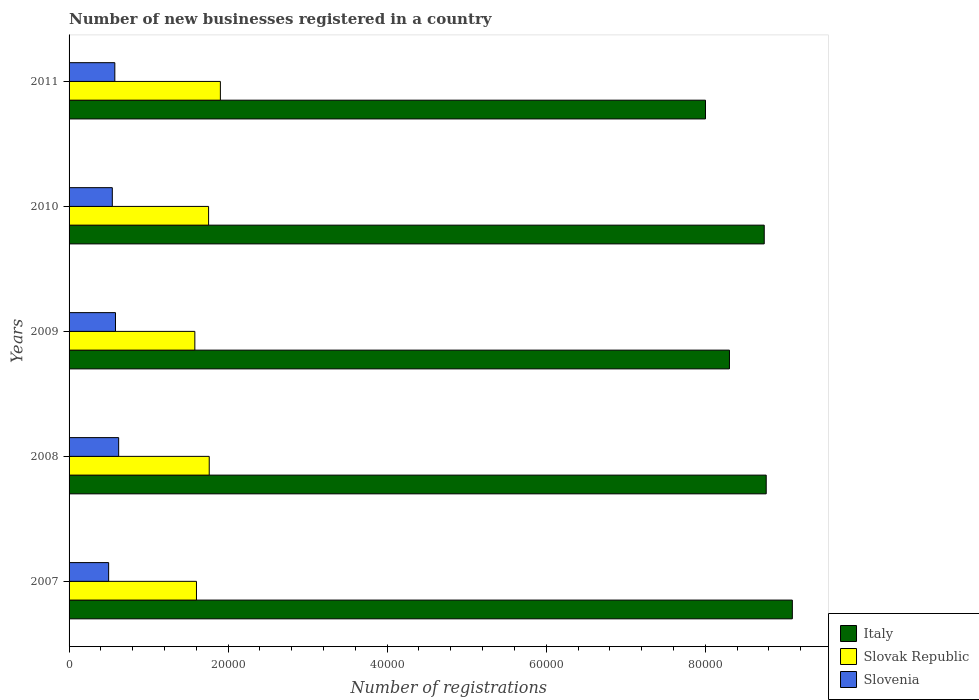How many different coloured bars are there?
Give a very brief answer. 3. Are the number of bars on each tick of the Y-axis equal?
Make the answer very short. Yes. How many bars are there on the 5th tick from the bottom?
Offer a very short reply. 3. What is the label of the 1st group of bars from the top?
Provide a succinct answer. 2011. In how many cases, is the number of bars for a given year not equal to the number of legend labels?
Your response must be concise. 0. What is the number of new businesses registered in Italy in 2010?
Provide a short and direct response. 8.74e+04. Across all years, what is the maximum number of new businesses registered in Slovenia?
Keep it short and to the point. 6235. Across all years, what is the minimum number of new businesses registered in Italy?
Offer a very short reply. 8.00e+04. In which year was the number of new businesses registered in Slovak Republic maximum?
Provide a short and direct response. 2011. What is the total number of new businesses registered in Italy in the graph?
Provide a succinct answer. 4.29e+05. What is the difference between the number of new businesses registered in Slovak Republic in 2009 and that in 2011?
Offer a terse response. -3211. What is the difference between the number of new businesses registered in Italy in 2009 and the number of new businesses registered in Slovak Republic in 2011?
Provide a succinct answer. 6.40e+04. What is the average number of new businesses registered in Slovak Republic per year?
Your answer should be compact. 1.72e+04. In the year 2009, what is the difference between the number of new businesses registered in Slovak Republic and number of new businesses registered in Slovenia?
Provide a succinct answer. 9979. In how many years, is the number of new businesses registered in Slovenia greater than 60000 ?
Provide a short and direct response. 0. What is the ratio of the number of new businesses registered in Italy in 2009 to that in 2011?
Provide a succinct answer. 1.04. Is the number of new businesses registered in Slovak Republic in 2010 less than that in 2011?
Provide a succinct answer. Yes. What is the difference between the highest and the second highest number of new businesses registered in Slovak Republic?
Offer a very short reply. 1401. What is the difference between the highest and the lowest number of new businesses registered in Slovenia?
Keep it short and to the point. 1259. In how many years, is the number of new businesses registered in Italy greater than the average number of new businesses registered in Italy taken over all years?
Provide a succinct answer. 3. Is the sum of the number of new businesses registered in Slovenia in 2010 and 2011 greater than the maximum number of new businesses registered in Slovak Republic across all years?
Give a very brief answer. No. What does the 2nd bar from the bottom in 2009 represents?
Give a very brief answer. Slovak Republic. Is it the case that in every year, the sum of the number of new businesses registered in Slovenia and number of new businesses registered in Slovak Republic is greater than the number of new businesses registered in Italy?
Provide a succinct answer. No. Are all the bars in the graph horizontal?
Offer a very short reply. Yes. What is the difference between two consecutive major ticks on the X-axis?
Provide a succinct answer. 2.00e+04. Does the graph contain any zero values?
Your response must be concise. No. Does the graph contain grids?
Provide a succinct answer. No. Where does the legend appear in the graph?
Offer a very short reply. Bottom right. How many legend labels are there?
Your answer should be very brief. 3. How are the legend labels stacked?
Provide a short and direct response. Vertical. What is the title of the graph?
Your response must be concise. Number of new businesses registered in a country. What is the label or title of the X-axis?
Your answer should be very brief. Number of registrations. What is the label or title of the Y-axis?
Ensure brevity in your answer.  Years. What is the Number of registrations in Italy in 2007?
Provide a succinct answer. 9.10e+04. What is the Number of registrations of Slovak Republic in 2007?
Your response must be concise. 1.60e+04. What is the Number of registrations of Slovenia in 2007?
Provide a succinct answer. 4976. What is the Number of registrations of Italy in 2008?
Your answer should be compact. 8.77e+04. What is the Number of registrations in Slovak Republic in 2008?
Ensure brevity in your answer.  1.76e+04. What is the Number of registrations in Slovenia in 2008?
Your answer should be very brief. 6235. What is the Number of registrations of Italy in 2009?
Provide a short and direct response. 8.30e+04. What is the Number of registrations of Slovak Republic in 2009?
Offer a terse response. 1.58e+04. What is the Number of registrations in Slovenia in 2009?
Ensure brevity in your answer.  5836. What is the Number of registrations of Italy in 2010?
Your answer should be very brief. 8.74e+04. What is the Number of registrations of Slovak Republic in 2010?
Make the answer very short. 1.75e+04. What is the Number of registrations of Slovenia in 2010?
Your response must be concise. 5438. What is the Number of registrations of Italy in 2011?
Your response must be concise. 8.00e+04. What is the Number of registrations in Slovak Republic in 2011?
Offer a very short reply. 1.90e+04. What is the Number of registrations in Slovenia in 2011?
Your answer should be very brief. 5754. Across all years, what is the maximum Number of registrations of Italy?
Give a very brief answer. 9.10e+04. Across all years, what is the maximum Number of registrations of Slovak Republic?
Provide a succinct answer. 1.90e+04. Across all years, what is the maximum Number of registrations of Slovenia?
Offer a very short reply. 6235. Across all years, what is the minimum Number of registrations in Italy?
Your answer should be compact. 8.00e+04. Across all years, what is the minimum Number of registrations of Slovak Republic?
Your answer should be very brief. 1.58e+04. Across all years, what is the minimum Number of registrations in Slovenia?
Keep it short and to the point. 4976. What is the total Number of registrations in Italy in the graph?
Keep it short and to the point. 4.29e+05. What is the total Number of registrations in Slovak Republic in the graph?
Give a very brief answer. 8.60e+04. What is the total Number of registrations of Slovenia in the graph?
Your response must be concise. 2.82e+04. What is the difference between the Number of registrations of Italy in 2007 and that in 2008?
Your answer should be very brief. 3285. What is the difference between the Number of registrations in Slovak Republic in 2007 and that in 2008?
Provide a short and direct response. -1605. What is the difference between the Number of registrations of Slovenia in 2007 and that in 2008?
Provide a succinct answer. -1259. What is the difference between the Number of registrations in Italy in 2007 and that in 2009?
Your response must be concise. 7908. What is the difference between the Number of registrations of Slovak Republic in 2007 and that in 2009?
Your response must be concise. 205. What is the difference between the Number of registrations in Slovenia in 2007 and that in 2009?
Your answer should be compact. -860. What is the difference between the Number of registrations in Italy in 2007 and that in 2010?
Offer a terse response. 3535. What is the difference between the Number of registrations of Slovak Republic in 2007 and that in 2010?
Keep it short and to the point. -1524. What is the difference between the Number of registrations in Slovenia in 2007 and that in 2010?
Give a very brief answer. -462. What is the difference between the Number of registrations of Italy in 2007 and that in 2011?
Offer a very short reply. 1.09e+04. What is the difference between the Number of registrations in Slovak Republic in 2007 and that in 2011?
Your answer should be compact. -3006. What is the difference between the Number of registrations in Slovenia in 2007 and that in 2011?
Provide a short and direct response. -778. What is the difference between the Number of registrations in Italy in 2008 and that in 2009?
Ensure brevity in your answer.  4623. What is the difference between the Number of registrations of Slovak Republic in 2008 and that in 2009?
Offer a very short reply. 1810. What is the difference between the Number of registrations of Slovenia in 2008 and that in 2009?
Offer a terse response. 399. What is the difference between the Number of registrations of Italy in 2008 and that in 2010?
Offer a terse response. 250. What is the difference between the Number of registrations in Slovak Republic in 2008 and that in 2010?
Give a very brief answer. 81. What is the difference between the Number of registrations of Slovenia in 2008 and that in 2010?
Your response must be concise. 797. What is the difference between the Number of registrations in Italy in 2008 and that in 2011?
Your answer should be very brief. 7637. What is the difference between the Number of registrations of Slovak Republic in 2008 and that in 2011?
Give a very brief answer. -1401. What is the difference between the Number of registrations in Slovenia in 2008 and that in 2011?
Give a very brief answer. 481. What is the difference between the Number of registrations in Italy in 2009 and that in 2010?
Give a very brief answer. -4373. What is the difference between the Number of registrations in Slovak Republic in 2009 and that in 2010?
Give a very brief answer. -1729. What is the difference between the Number of registrations in Slovenia in 2009 and that in 2010?
Provide a succinct answer. 398. What is the difference between the Number of registrations in Italy in 2009 and that in 2011?
Offer a terse response. 3014. What is the difference between the Number of registrations of Slovak Republic in 2009 and that in 2011?
Your answer should be compact. -3211. What is the difference between the Number of registrations in Slovenia in 2009 and that in 2011?
Your answer should be very brief. 82. What is the difference between the Number of registrations in Italy in 2010 and that in 2011?
Offer a very short reply. 7387. What is the difference between the Number of registrations of Slovak Republic in 2010 and that in 2011?
Provide a short and direct response. -1482. What is the difference between the Number of registrations of Slovenia in 2010 and that in 2011?
Give a very brief answer. -316. What is the difference between the Number of registrations in Italy in 2007 and the Number of registrations in Slovak Republic in 2008?
Your response must be concise. 7.33e+04. What is the difference between the Number of registrations of Italy in 2007 and the Number of registrations of Slovenia in 2008?
Your response must be concise. 8.47e+04. What is the difference between the Number of registrations in Slovak Republic in 2007 and the Number of registrations in Slovenia in 2008?
Provide a short and direct response. 9785. What is the difference between the Number of registrations of Italy in 2007 and the Number of registrations of Slovak Republic in 2009?
Your response must be concise. 7.51e+04. What is the difference between the Number of registrations of Italy in 2007 and the Number of registrations of Slovenia in 2009?
Provide a succinct answer. 8.51e+04. What is the difference between the Number of registrations in Slovak Republic in 2007 and the Number of registrations in Slovenia in 2009?
Provide a short and direct response. 1.02e+04. What is the difference between the Number of registrations in Italy in 2007 and the Number of registrations in Slovak Republic in 2010?
Your response must be concise. 7.34e+04. What is the difference between the Number of registrations in Italy in 2007 and the Number of registrations in Slovenia in 2010?
Your response must be concise. 8.55e+04. What is the difference between the Number of registrations of Slovak Republic in 2007 and the Number of registrations of Slovenia in 2010?
Your answer should be very brief. 1.06e+04. What is the difference between the Number of registrations of Italy in 2007 and the Number of registrations of Slovak Republic in 2011?
Provide a succinct answer. 7.19e+04. What is the difference between the Number of registrations in Italy in 2007 and the Number of registrations in Slovenia in 2011?
Your answer should be compact. 8.52e+04. What is the difference between the Number of registrations of Slovak Republic in 2007 and the Number of registrations of Slovenia in 2011?
Your response must be concise. 1.03e+04. What is the difference between the Number of registrations of Italy in 2008 and the Number of registrations of Slovak Republic in 2009?
Give a very brief answer. 7.18e+04. What is the difference between the Number of registrations of Italy in 2008 and the Number of registrations of Slovenia in 2009?
Provide a succinct answer. 8.18e+04. What is the difference between the Number of registrations in Slovak Republic in 2008 and the Number of registrations in Slovenia in 2009?
Provide a short and direct response. 1.18e+04. What is the difference between the Number of registrations in Italy in 2008 and the Number of registrations in Slovak Republic in 2010?
Your answer should be compact. 7.01e+04. What is the difference between the Number of registrations of Italy in 2008 and the Number of registrations of Slovenia in 2010?
Offer a very short reply. 8.22e+04. What is the difference between the Number of registrations in Slovak Republic in 2008 and the Number of registrations in Slovenia in 2010?
Make the answer very short. 1.22e+04. What is the difference between the Number of registrations in Italy in 2008 and the Number of registrations in Slovak Republic in 2011?
Ensure brevity in your answer.  6.86e+04. What is the difference between the Number of registrations of Italy in 2008 and the Number of registrations of Slovenia in 2011?
Your answer should be very brief. 8.19e+04. What is the difference between the Number of registrations in Slovak Republic in 2008 and the Number of registrations in Slovenia in 2011?
Ensure brevity in your answer.  1.19e+04. What is the difference between the Number of registrations in Italy in 2009 and the Number of registrations in Slovak Republic in 2010?
Give a very brief answer. 6.55e+04. What is the difference between the Number of registrations in Italy in 2009 and the Number of registrations in Slovenia in 2010?
Keep it short and to the point. 7.76e+04. What is the difference between the Number of registrations of Slovak Republic in 2009 and the Number of registrations of Slovenia in 2010?
Offer a terse response. 1.04e+04. What is the difference between the Number of registrations in Italy in 2009 and the Number of registrations in Slovak Republic in 2011?
Make the answer very short. 6.40e+04. What is the difference between the Number of registrations in Italy in 2009 and the Number of registrations in Slovenia in 2011?
Provide a succinct answer. 7.73e+04. What is the difference between the Number of registrations of Slovak Republic in 2009 and the Number of registrations of Slovenia in 2011?
Keep it short and to the point. 1.01e+04. What is the difference between the Number of registrations of Italy in 2010 and the Number of registrations of Slovak Republic in 2011?
Make the answer very short. 6.84e+04. What is the difference between the Number of registrations in Italy in 2010 and the Number of registrations in Slovenia in 2011?
Your answer should be compact. 8.17e+04. What is the difference between the Number of registrations of Slovak Republic in 2010 and the Number of registrations of Slovenia in 2011?
Your answer should be compact. 1.18e+04. What is the average Number of registrations in Italy per year?
Provide a succinct answer. 8.58e+04. What is the average Number of registrations of Slovak Republic per year?
Keep it short and to the point. 1.72e+04. What is the average Number of registrations in Slovenia per year?
Give a very brief answer. 5647.8. In the year 2007, what is the difference between the Number of registrations of Italy and Number of registrations of Slovak Republic?
Your response must be concise. 7.49e+04. In the year 2007, what is the difference between the Number of registrations in Italy and Number of registrations in Slovenia?
Provide a short and direct response. 8.60e+04. In the year 2007, what is the difference between the Number of registrations in Slovak Republic and Number of registrations in Slovenia?
Provide a short and direct response. 1.10e+04. In the year 2008, what is the difference between the Number of registrations of Italy and Number of registrations of Slovak Republic?
Your answer should be compact. 7.00e+04. In the year 2008, what is the difference between the Number of registrations of Italy and Number of registrations of Slovenia?
Your answer should be very brief. 8.14e+04. In the year 2008, what is the difference between the Number of registrations of Slovak Republic and Number of registrations of Slovenia?
Make the answer very short. 1.14e+04. In the year 2009, what is the difference between the Number of registrations in Italy and Number of registrations in Slovak Republic?
Your answer should be compact. 6.72e+04. In the year 2009, what is the difference between the Number of registrations of Italy and Number of registrations of Slovenia?
Make the answer very short. 7.72e+04. In the year 2009, what is the difference between the Number of registrations in Slovak Republic and Number of registrations in Slovenia?
Your answer should be very brief. 9979. In the year 2010, what is the difference between the Number of registrations in Italy and Number of registrations in Slovak Republic?
Keep it short and to the point. 6.99e+04. In the year 2010, what is the difference between the Number of registrations of Italy and Number of registrations of Slovenia?
Provide a succinct answer. 8.20e+04. In the year 2010, what is the difference between the Number of registrations in Slovak Republic and Number of registrations in Slovenia?
Provide a short and direct response. 1.21e+04. In the year 2011, what is the difference between the Number of registrations of Italy and Number of registrations of Slovak Republic?
Offer a very short reply. 6.10e+04. In the year 2011, what is the difference between the Number of registrations in Italy and Number of registrations in Slovenia?
Your response must be concise. 7.43e+04. In the year 2011, what is the difference between the Number of registrations in Slovak Republic and Number of registrations in Slovenia?
Your answer should be compact. 1.33e+04. What is the ratio of the Number of registrations of Italy in 2007 to that in 2008?
Provide a succinct answer. 1.04. What is the ratio of the Number of registrations in Slovak Republic in 2007 to that in 2008?
Provide a succinct answer. 0.91. What is the ratio of the Number of registrations in Slovenia in 2007 to that in 2008?
Offer a terse response. 0.8. What is the ratio of the Number of registrations of Italy in 2007 to that in 2009?
Provide a succinct answer. 1.1. What is the ratio of the Number of registrations of Slovak Republic in 2007 to that in 2009?
Your answer should be compact. 1.01. What is the ratio of the Number of registrations in Slovenia in 2007 to that in 2009?
Ensure brevity in your answer.  0.85. What is the ratio of the Number of registrations of Italy in 2007 to that in 2010?
Offer a very short reply. 1.04. What is the ratio of the Number of registrations of Slovak Republic in 2007 to that in 2010?
Offer a terse response. 0.91. What is the ratio of the Number of registrations in Slovenia in 2007 to that in 2010?
Ensure brevity in your answer.  0.92. What is the ratio of the Number of registrations in Italy in 2007 to that in 2011?
Provide a short and direct response. 1.14. What is the ratio of the Number of registrations of Slovak Republic in 2007 to that in 2011?
Provide a succinct answer. 0.84. What is the ratio of the Number of registrations in Slovenia in 2007 to that in 2011?
Give a very brief answer. 0.86. What is the ratio of the Number of registrations in Italy in 2008 to that in 2009?
Your response must be concise. 1.06. What is the ratio of the Number of registrations in Slovak Republic in 2008 to that in 2009?
Ensure brevity in your answer.  1.11. What is the ratio of the Number of registrations of Slovenia in 2008 to that in 2009?
Your answer should be compact. 1.07. What is the ratio of the Number of registrations in Slovenia in 2008 to that in 2010?
Ensure brevity in your answer.  1.15. What is the ratio of the Number of registrations in Italy in 2008 to that in 2011?
Offer a terse response. 1.1. What is the ratio of the Number of registrations in Slovak Republic in 2008 to that in 2011?
Provide a short and direct response. 0.93. What is the ratio of the Number of registrations of Slovenia in 2008 to that in 2011?
Provide a short and direct response. 1.08. What is the ratio of the Number of registrations in Slovak Republic in 2009 to that in 2010?
Ensure brevity in your answer.  0.9. What is the ratio of the Number of registrations of Slovenia in 2009 to that in 2010?
Make the answer very short. 1.07. What is the ratio of the Number of registrations of Italy in 2009 to that in 2011?
Provide a short and direct response. 1.04. What is the ratio of the Number of registrations in Slovak Republic in 2009 to that in 2011?
Offer a very short reply. 0.83. What is the ratio of the Number of registrations of Slovenia in 2009 to that in 2011?
Provide a short and direct response. 1.01. What is the ratio of the Number of registrations of Italy in 2010 to that in 2011?
Ensure brevity in your answer.  1.09. What is the ratio of the Number of registrations in Slovak Republic in 2010 to that in 2011?
Your answer should be very brief. 0.92. What is the ratio of the Number of registrations in Slovenia in 2010 to that in 2011?
Ensure brevity in your answer.  0.95. What is the difference between the highest and the second highest Number of registrations of Italy?
Provide a succinct answer. 3285. What is the difference between the highest and the second highest Number of registrations in Slovak Republic?
Make the answer very short. 1401. What is the difference between the highest and the second highest Number of registrations in Slovenia?
Provide a short and direct response. 399. What is the difference between the highest and the lowest Number of registrations in Italy?
Offer a terse response. 1.09e+04. What is the difference between the highest and the lowest Number of registrations of Slovak Republic?
Make the answer very short. 3211. What is the difference between the highest and the lowest Number of registrations in Slovenia?
Provide a succinct answer. 1259. 